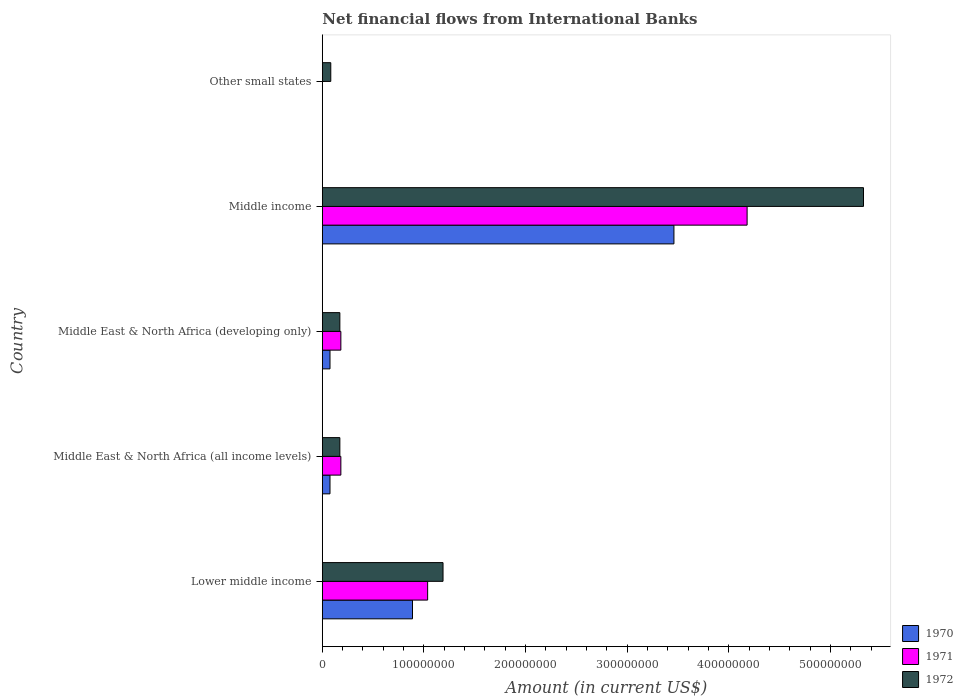Are the number of bars per tick equal to the number of legend labels?
Make the answer very short. No. Are the number of bars on each tick of the Y-axis equal?
Make the answer very short. No. How many bars are there on the 5th tick from the top?
Provide a succinct answer. 3. What is the label of the 1st group of bars from the top?
Your answer should be compact. Other small states. In how many cases, is the number of bars for a given country not equal to the number of legend labels?
Your answer should be compact. 1. What is the net financial aid flows in 1971 in Middle income?
Provide a short and direct response. 4.18e+08. Across all countries, what is the maximum net financial aid flows in 1971?
Provide a succinct answer. 4.18e+08. What is the total net financial aid flows in 1972 in the graph?
Offer a terse response. 6.94e+08. What is the difference between the net financial aid flows in 1971 in Middle East & North Africa (developing only) and that in Middle income?
Offer a very short reply. -4.00e+08. What is the difference between the net financial aid flows in 1972 in Middle income and the net financial aid flows in 1970 in Other small states?
Offer a very short reply. 5.32e+08. What is the average net financial aid flows in 1971 per country?
Provide a succinct answer. 1.12e+08. What is the difference between the net financial aid flows in 1971 and net financial aid flows in 1972 in Middle East & North Africa (developing only)?
Your answer should be very brief. 9.78e+05. What is the ratio of the net financial aid flows in 1972 in Lower middle income to that in Middle income?
Ensure brevity in your answer.  0.22. Is the difference between the net financial aid flows in 1971 in Middle East & North Africa (all income levels) and Middle East & North Africa (developing only) greater than the difference between the net financial aid flows in 1972 in Middle East & North Africa (all income levels) and Middle East & North Africa (developing only)?
Your answer should be very brief. No. What is the difference between the highest and the second highest net financial aid flows in 1972?
Your answer should be compact. 4.14e+08. What is the difference between the highest and the lowest net financial aid flows in 1971?
Keep it short and to the point. 4.18e+08. Is the sum of the net financial aid flows in 1970 in Lower middle income and Middle East & North Africa (developing only) greater than the maximum net financial aid flows in 1971 across all countries?
Your response must be concise. No. Is it the case that in every country, the sum of the net financial aid flows in 1970 and net financial aid flows in 1971 is greater than the net financial aid flows in 1972?
Your answer should be compact. No. Are all the bars in the graph horizontal?
Your answer should be very brief. Yes. How many countries are there in the graph?
Give a very brief answer. 5. What is the difference between two consecutive major ticks on the X-axis?
Ensure brevity in your answer.  1.00e+08. Are the values on the major ticks of X-axis written in scientific E-notation?
Keep it short and to the point. No. Where does the legend appear in the graph?
Your answer should be very brief. Bottom right. What is the title of the graph?
Ensure brevity in your answer.  Net financial flows from International Banks. Does "2013" appear as one of the legend labels in the graph?
Provide a succinct answer. No. What is the label or title of the Y-axis?
Offer a very short reply. Country. What is the Amount (in current US$) in 1970 in Lower middle income?
Your answer should be very brief. 8.87e+07. What is the Amount (in current US$) in 1971 in Lower middle income?
Your answer should be compact. 1.04e+08. What is the Amount (in current US$) in 1972 in Lower middle income?
Keep it short and to the point. 1.19e+08. What is the Amount (in current US$) of 1970 in Middle East & North Africa (all income levels)?
Provide a short and direct response. 7.55e+06. What is the Amount (in current US$) of 1971 in Middle East & North Africa (all income levels)?
Offer a very short reply. 1.82e+07. What is the Amount (in current US$) in 1972 in Middle East & North Africa (all income levels)?
Keep it short and to the point. 1.73e+07. What is the Amount (in current US$) of 1970 in Middle East & North Africa (developing only)?
Your response must be concise. 7.55e+06. What is the Amount (in current US$) of 1971 in Middle East & North Africa (developing only)?
Ensure brevity in your answer.  1.82e+07. What is the Amount (in current US$) of 1972 in Middle East & North Africa (developing only)?
Offer a terse response. 1.73e+07. What is the Amount (in current US$) of 1970 in Middle income?
Offer a terse response. 3.46e+08. What is the Amount (in current US$) of 1971 in Middle income?
Offer a very short reply. 4.18e+08. What is the Amount (in current US$) of 1972 in Middle income?
Offer a very short reply. 5.32e+08. What is the Amount (in current US$) in 1970 in Other small states?
Keep it short and to the point. 0. What is the Amount (in current US$) of 1972 in Other small states?
Offer a very short reply. 8.31e+06. Across all countries, what is the maximum Amount (in current US$) of 1970?
Your answer should be very brief. 3.46e+08. Across all countries, what is the maximum Amount (in current US$) in 1971?
Provide a short and direct response. 4.18e+08. Across all countries, what is the maximum Amount (in current US$) of 1972?
Offer a terse response. 5.32e+08. Across all countries, what is the minimum Amount (in current US$) in 1972?
Offer a very short reply. 8.31e+06. What is the total Amount (in current US$) in 1970 in the graph?
Keep it short and to the point. 4.50e+08. What is the total Amount (in current US$) in 1971 in the graph?
Provide a short and direct response. 5.58e+08. What is the total Amount (in current US$) of 1972 in the graph?
Provide a short and direct response. 6.94e+08. What is the difference between the Amount (in current US$) in 1970 in Lower middle income and that in Middle East & North Africa (all income levels)?
Your answer should be very brief. 8.12e+07. What is the difference between the Amount (in current US$) of 1971 in Lower middle income and that in Middle East & North Africa (all income levels)?
Your response must be concise. 8.54e+07. What is the difference between the Amount (in current US$) of 1972 in Lower middle income and that in Middle East & North Africa (all income levels)?
Provide a short and direct response. 1.02e+08. What is the difference between the Amount (in current US$) of 1970 in Lower middle income and that in Middle East & North Africa (developing only)?
Offer a terse response. 8.12e+07. What is the difference between the Amount (in current US$) in 1971 in Lower middle income and that in Middle East & North Africa (developing only)?
Your answer should be very brief. 8.54e+07. What is the difference between the Amount (in current US$) in 1972 in Lower middle income and that in Middle East & North Africa (developing only)?
Ensure brevity in your answer.  1.02e+08. What is the difference between the Amount (in current US$) in 1970 in Lower middle income and that in Middle income?
Offer a very short reply. -2.57e+08. What is the difference between the Amount (in current US$) of 1971 in Lower middle income and that in Middle income?
Your answer should be compact. -3.14e+08. What is the difference between the Amount (in current US$) in 1972 in Lower middle income and that in Middle income?
Ensure brevity in your answer.  -4.14e+08. What is the difference between the Amount (in current US$) in 1972 in Lower middle income and that in Other small states?
Keep it short and to the point. 1.10e+08. What is the difference between the Amount (in current US$) of 1970 in Middle East & North Africa (all income levels) and that in Middle East & North Africa (developing only)?
Offer a very short reply. 0. What is the difference between the Amount (in current US$) in 1970 in Middle East & North Africa (all income levels) and that in Middle income?
Your answer should be compact. -3.38e+08. What is the difference between the Amount (in current US$) of 1971 in Middle East & North Africa (all income levels) and that in Middle income?
Offer a terse response. -4.00e+08. What is the difference between the Amount (in current US$) of 1972 in Middle East & North Africa (all income levels) and that in Middle income?
Give a very brief answer. -5.15e+08. What is the difference between the Amount (in current US$) of 1972 in Middle East & North Africa (all income levels) and that in Other small states?
Make the answer very short. 8.94e+06. What is the difference between the Amount (in current US$) of 1970 in Middle East & North Africa (developing only) and that in Middle income?
Make the answer very short. -3.38e+08. What is the difference between the Amount (in current US$) of 1971 in Middle East & North Africa (developing only) and that in Middle income?
Make the answer very short. -4.00e+08. What is the difference between the Amount (in current US$) in 1972 in Middle East & North Africa (developing only) and that in Middle income?
Keep it short and to the point. -5.15e+08. What is the difference between the Amount (in current US$) in 1972 in Middle East & North Africa (developing only) and that in Other small states?
Offer a very short reply. 8.94e+06. What is the difference between the Amount (in current US$) of 1972 in Middle income and that in Other small states?
Offer a terse response. 5.24e+08. What is the difference between the Amount (in current US$) in 1970 in Lower middle income and the Amount (in current US$) in 1971 in Middle East & North Africa (all income levels)?
Your response must be concise. 7.05e+07. What is the difference between the Amount (in current US$) of 1970 in Lower middle income and the Amount (in current US$) of 1972 in Middle East & North Africa (all income levels)?
Provide a succinct answer. 7.15e+07. What is the difference between the Amount (in current US$) of 1971 in Lower middle income and the Amount (in current US$) of 1972 in Middle East & North Africa (all income levels)?
Provide a short and direct response. 8.64e+07. What is the difference between the Amount (in current US$) in 1970 in Lower middle income and the Amount (in current US$) in 1971 in Middle East & North Africa (developing only)?
Offer a very short reply. 7.05e+07. What is the difference between the Amount (in current US$) of 1970 in Lower middle income and the Amount (in current US$) of 1972 in Middle East & North Africa (developing only)?
Provide a succinct answer. 7.15e+07. What is the difference between the Amount (in current US$) in 1971 in Lower middle income and the Amount (in current US$) in 1972 in Middle East & North Africa (developing only)?
Your answer should be very brief. 8.64e+07. What is the difference between the Amount (in current US$) of 1970 in Lower middle income and the Amount (in current US$) of 1971 in Middle income?
Provide a succinct answer. -3.29e+08. What is the difference between the Amount (in current US$) of 1970 in Lower middle income and the Amount (in current US$) of 1972 in Middle income?
Offer a terse response. -4.44e+08. What is the difference between the Amount (in current US$) of 1971 in Lower middle income and the Amount (in current US$) of 1972 in Middle income?
Provide a succinct answer. -4.29e+08. What is the difference between the Amount (in current US$) in 1970 in Lower middle income and the Amount (in current US$) in 1972 in Other small states?
Provide a succinct answer. 8.04e+07. What is the difference between the Amount (in current US$) of 1971 in Lower middle income and the Amount (in current US$) of 1972 in Other small states?
Your response must be concise. 9.53e+07. What is the difference between the Amount (in current US$) of 1970 in Middle East & North Africa (all income levels) and the Amount (in current US$) of 1971 in Middle East & North Africa (developing only)?
Offer a very short reply. -1.07e+07. What is the difference between the Amount (in current US$) in 1970 in Middle East & North Africa (all income levels) and the Amount (in current US$) in 1972 in Middle East & North Africa (developing only)?
Your answer should be compact. -9.70e+06. What is the difference between the Amount (in current US$) in 1971 in Middle East & North Africa (all income levels) and the Amount (in current US$) in 1972 in Middle East & North Africa (developing only)?
Ensure brevity in your answer.  9.78e+05. What is the difference between the Amount (in current US$) of 1970 in Middle East & North Africa (all income levels) and the Amount (in current US$) of 1971 in Middle income?
Provide a short and direct response. -4.10e+08. What is the difference between the Amount (in current US$) of 1970 in Middle East & North Africa (all income levels) and the Amount (in current US$) of 1972 in Middle income?
Your answer should be very brief. -5.25e+08. What is the difference between the Amount (in current US$) of 1971 in Middle East & North Africa (all income levels) and the Amount (in current US$) of 1972 in Middle income?
Provide a short and direct response. -5.14e+08. What is the difference between the Amount (in current US$) of 1970 in Middle East & North Africa (all income levels) and the Amount (in current US$) of 1972 in Other small states?
Offer a terse response. -7.62e+05. What is the difference between the Amount (in current US$) in 1971 in Middle East & North Africa (all income levels) and the Amount (in current US$) in 1972 in Other small states?
Give a very brief answer. 9.92e+06. What is the difference between the Amount (in current US$) of 1970 in Middle East & North Africa (developing only) and the Amount (in current US$) of 1971 in Middle income?
Your answer should be very brief. -4.10e+08. What is the difference between the Amount (in current US$) in 1970 in Middle East & North Africa (developing only) and the Amount (in current US$) in 1972 in Middle income?
Provide a short and direct response. -5.25e+08. What is the difference between the Amount (in current US$) in 1971 in Middle East & North Africa (developing only) and the Amount (in current US$) in 1972 in Middle income?
Your answer should be very brief. -5.14e+08. What is the difference between the Amount (in current US$) of 1970 in Middle East & North Africa (developing only) and the Amount (in current US$) of 1972 in Other small states?
Make the answer very short. -7.62e+05. What is the difference between the Amount (in current US$) of 1971 in Middle East & North Africa (developing only) and the Amount (in current US$) of 1972 in Other small states?
Offer a very short reply. 9.92e+06. What is the difference between the Amount (in current US$) of 1970 in Middle income and the Amount (in current US$) of 1972 in Other small states?
Keep it short and to the point. 3.38e+08. What is the difference between the Amount (in current US$) of 1971 in Middle income and the Amount (in current US$) of 1972 in Other small states?
Make the answer very short. 4.10e+08. What is the average Amount (in current US$) in 1970 per country?
Offer a very short reply. 9.00e+07. What is the average Amount (in current US$) in 1971 per country?
Keep it short and to the point. 1.12e+08. What is the average Amount (in current US$) in 1972 per country?
Give a very brief answer. 1.39e+08. What is the difference between the Amount (in current US$) in 1970 and Amount (in current US$) in 1971 in Lower middle income?
Your response must be concise. -1.49e+07. What is the difference between the Amount (in current US$) in 1970 and Amount (in current US$) in 1972 in Lower middle income?
Your response must be concise. -3.00e+07. What is the difference between the Amount (in current US$) of 1971 and Amount (in current US$) of 1972 in Lower middle income?
Keep it short and to the point. -1.51e+07. What is the difference between the Amount (in current US$) in 1970 and Amount (in current US$) in 1971 in Middle East & North Africa (all income levels)?
Your answer should be compact. -1.07e+07. What is the difference between the Amount (in current US$) in 1970 and Amount (in current US$) in 1972 in Middle East & North Africa (all income levels)?
Ensure brevity in your answer.  -9.70e+06. What is the difference between the Amount (in current US$) in 1971 and Amount (in current US$) in 1972 in Middle East & North Africa (all income levels)?
Offer a very short reply. 9.78e+05. What is the difference between the Amount (in current US$) of 1970 and Amount (in current US$) of 1971 in Middle East & North Africa (developing only)?
Provide a succinct answer. -1.07e+07. What is the difference between the Amount (in current US$) in 1970 and Amount (in current US$) in 1972 in Middle East & North Africa (developing only)?
Keep it short and to the point. -9.70e+06. What is the difference between the Amount (in current US$) of 1971 and Amount (in current US$) of 1972 in Middle East & North Africa (developing only)?
Keep it short and to the point. 9.78e+05. What is the difference between the Amount (in current US$) of 1970 and Amount (in current US$) of 1971 in Middle income?
Offer a terse response. -7.20e+07. What is the difference between the Amount (in current US$) of 1970 and Amount (in current US$) of 1972 in Middle income?
Keep it short and to the point. -1.87e+08. What is the difference between the Amount (in current US$) in 1971 and Amount (in current US$) in 1972 in Middle income?
Your answer should be very brief. -1.15e+08. What is the ratio of the Amount (in current US$) in 1970 in Lower middle income to that in Middle East & North Africa (all income levels)?
Offer a very short reply. 11.76. What is the ratio of the Amount (in current US$) in 1971 in Lower middle income to that in Middle East & North Africa (all income levels)?
Your answer should be compact. 5.68. What is the ratio of the Amount (in current US$) in 1972 in Lower middle income to that in Middle East & North Africa (all income levels)?
Your response must be concise. 6.88. What is the ratio of the Amount (in current US$) in 1970 in Lower middle income to that in Middle East & North Africa (developing only)?
Offer a terse response. 11.76. What is the ratio of the Amount (in current US$) of 1971 in Lower middle income to that in Middle East & North Africa (developing only)?
Your answer should be very brief. 5.68. What is the ratio of the Amount (in current US$) of 1972 in Lower middle income to that in Middle East & North Africa (developing only)?
Your response must be concise. 6.88. What is the ratio of the Amount (in current US$) of 1970 in Lower middle income to that in Middle income?
Keep it short and to the point. 0.26. What is the ratio of the Amount (in current US$) in 1971 in Lower middle income to that in Middle income?
Offer a very short reply. 0.25. What is the ratio of the Amount (in current US$) in 1972 in Lower middle income to that in Middle income?
Make the answer very short. 0.22. What is the ratio of the Amount (in current US$) in 1972 in Lower middle income to that in Other small states?
Ensure brevity in your answer.  14.29. What is the ratio of the Amount (in current US$) in 1970 in Middle East & North Africa (all income levels) to that in Middle East & North Africa (developing only)?
Keep it short and to the point. 1. What is the ratio of the Amount (in current US$) of 1972 in Middle East & North Africa (all income levels) to that in Middle East & North Africa (developing only)?
Your answer should be very brief. 1. What is the ratio of the Amount (in current US$) in 1970 in Middle East & North Africa (all income levels) to that in Middle income?
Offer a terse response. 0.02. What is the ratio of the Amount (in current US$) in 1971 in Middle East & North Africa (all income levels) to that in Middle income?
Your response must be concise. 0.04. What is the ratio of the Amount (in current US$) of 1972 in Middle East & North Africa (all income levels) to that in Middle income?
Provide a short and direct response. 0.03. What is the ratio of the Amount (in current US$) in 1972 in Middle East & North Africa (all income levels) to that in Other small states?
Your answer should be compact. 2.08. What is the ratio of the Amount (in current US$) of 1970 in Middle East & North Africa (developing only) to that in Middle income?
Keep it short and to the point. 0.02. What is the ratio of the Amount (in current US$) in 1971 in Middle East & North Africa (developing only) to that in Middle income?
Your answer should be very brief. 0.04. What is the ratio of the Amount (in current US$) in 1972 in Middle East & North Africa (developing only) to that in Middle income?
Give a very brief answer. 0.03. What is the ratio of the Amount (in current US$) in 1972 in Middle East & North Africa (developing only) to that in Other small states?
Provide a short and direct response. 2.08. What is the ratio of the Amount (in current US$) of 1972 in Middle income to that in Other small states?
Keep it short and to the point. 64.08. What is the difference between the highest and the second highest Amount (in current US$) of 1970?
Your answer should be very brief. 2.57e+08. What is the difference between the highest and the second highest Amount (in current US$) of 1971?
Your answer should be compact. 3.14e+08. What is the difference between the highest and the second highest Amount (in current US$) in 1972?
Make the answer very short. 4.14e+08. What is the difference between the highest and the lowest Amount (in current US$) in 1970?
Offer a terse response. 3.46e+08. What is the difference between the highest and the lowest Amount (in current US$) in 1971?
Offer a terse response. 4.18e+08. What is the difference between the highest and the lowest Amount (in current US$) of 1972?
Provide a succinct answer. 5.24e+08. 